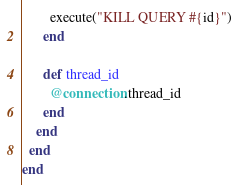<code> <loc_0><loc_0><loc_500><loc_500><_Ruby_>        execute("KILL QUERY #{id}")
      end

      def thread_id
        @connection.thread_id
      end
    end
  end
end
</code> 